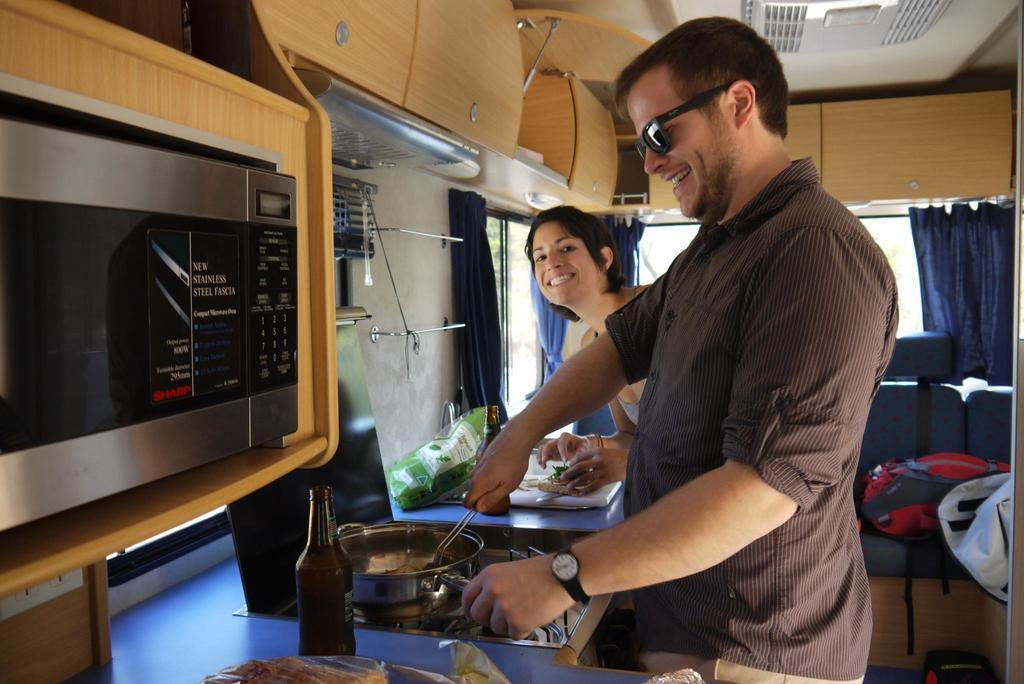Provide a one-sentence caption for the provided image. A man and woman are in a small kitchen that has a new stainless steel fascia labeled microwave. 